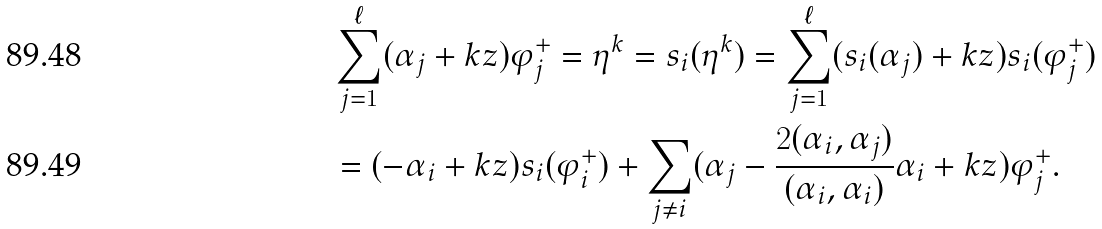<formula> <loc_0><loc_0><loc_500><loc_500>& \sum _ { j = 1 } ^ { \ell } ( \alpha _ { j } + k z ) \varphi _ { j } ^ { + } = \eta ^ { k } = s _ { i } ( \eta ^ { k } ) = \sum _ { j = 1 } ^ { \ell } ( s _ { i } ( \alpha _ { j } ) + k z ) s _ { i } ( \varphi _ { j } ^ { + } ) \\ & = ( - \alpha _ { i } + k z ) s _ { i } ( \varphi _ { i } ^ { + } ) + \sum _ { j \neq i } ( \alpha _ { j } - \frac { 2 ( \alpha _ { i } , \alpha _ { j } ) } { ( \alpha _ { i } , \alpha _ { i } ) } { \alpha } _ { i } + k z ) \varphi _ { j } ^ { + } .</formula> 